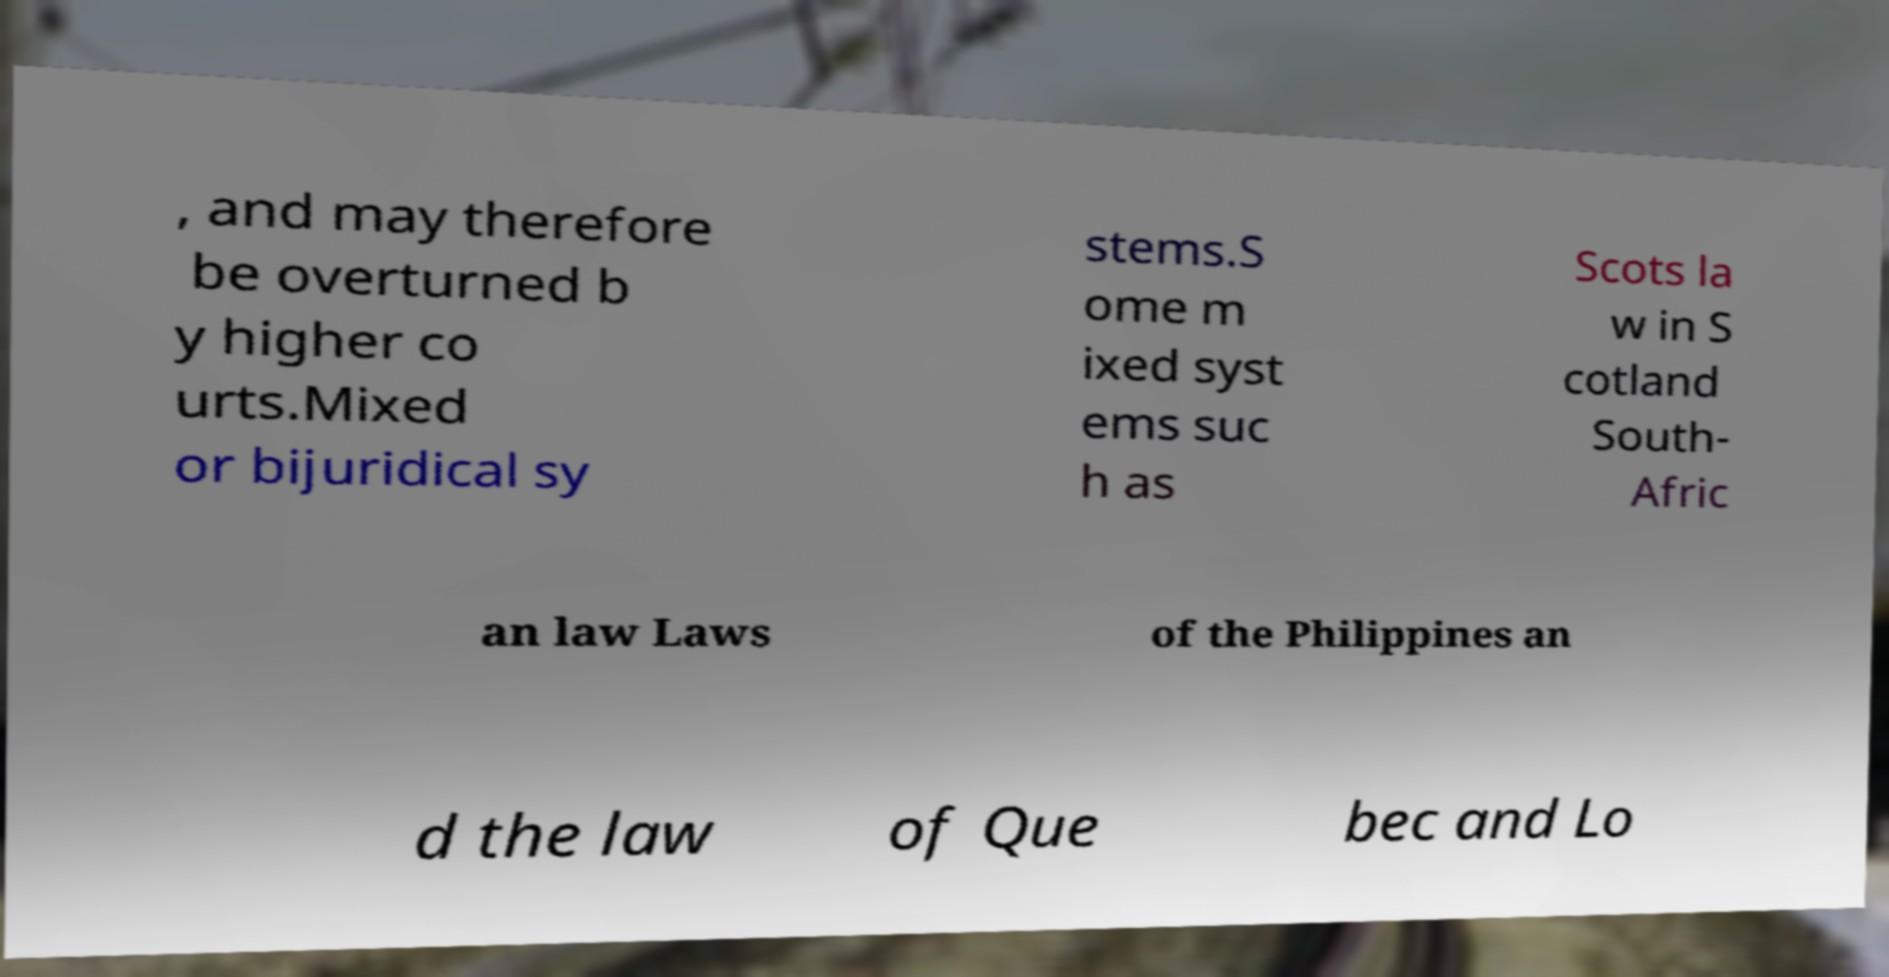There's text embedded in this image that I need extracted. Can you transcribe it verbatim? , and may therefore be overturned b y higher co urts.Mixed or bijuridical sy stems.S ome m ixed syst ems suc h as Scots la w in S cotland South- Afric an law Laws of the Philippines an d the law of Que bec and Lo 